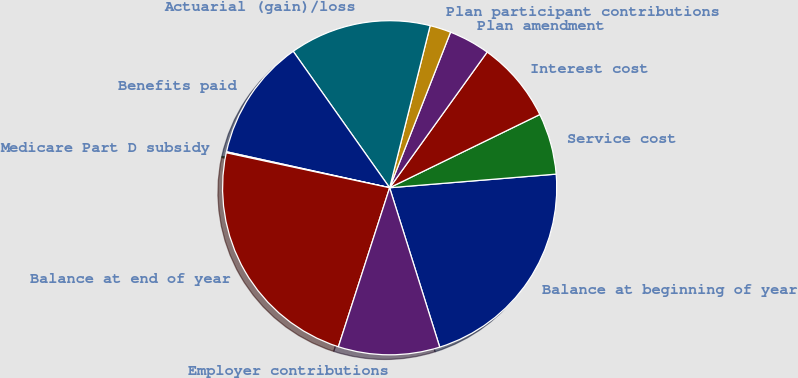<chart> <loc_0><loc_0><loc_500><loc_500><pie_chart><fcel>Balance at beginning of year<fcel>Service cost<fcel>Interest cost<fcel>Plan amendment<fcel>Plan participant contributions<fcel>Actuarial (gain)/loss<fcel>Benefits paid<fcel>Medicare Part D subsidy<fcel>Balance at end of year<fcel>Employer contributions<nl><fcel>21.45%<fcel>5.92%<fcel>7.86%<fcel>3.98%<fcel>2.04%<fcel>13.69%<fcel>11.75%<fcel>0.1%<fcel>23.39%<fcel>9.81%<nl></chart> 